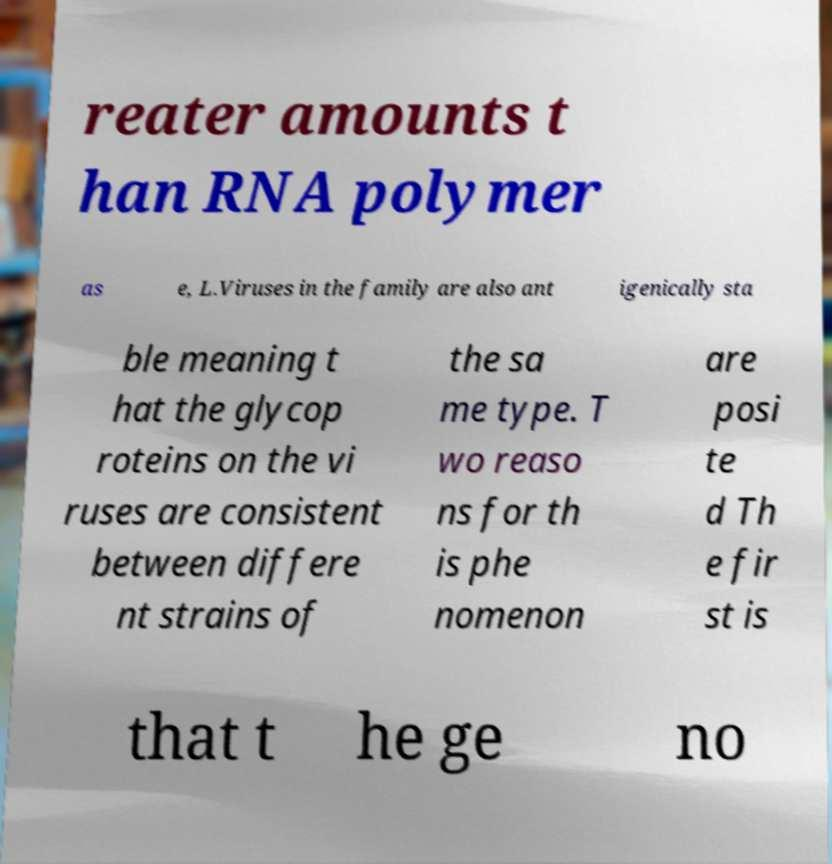Could you extract and type out the text from this image? reater amounts t han RNA polymer as e, L.Viruses in the family are also ant igenically sta ble meaning t hat the glycop roteins on the vi ruses are consistent between differe nt strains of the sa me type. T wo reaso ns for th is phe nomenon are posi te d Th e fir st is that t he ge no 